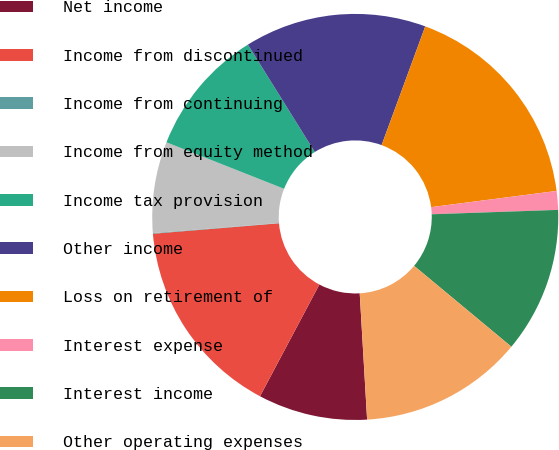Convert chart. <chart><loc_0><loc_0><loc_500><loc_500><pie_chart><fcel>Net income<fcel>Income from discontinued<fcel>Income from continuing<fcel>Income from equity method<fcel>Income tax provision<fcel>Other income<fcel>Loss on retirement of<fcel>Interest expense<fcel>Interest income<fcel>Other operating expenses<nl><fcel>8.7%<fcel>15.91%<fcel>0.05%<fcel>7.26%<fcel>10.14%<fcel>14.47%<fcel>17.35%<fcel>1.49%<fcel>11.59%<fcel>13.03%<nl></chart> 